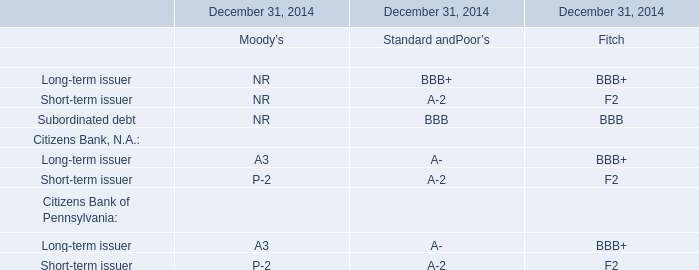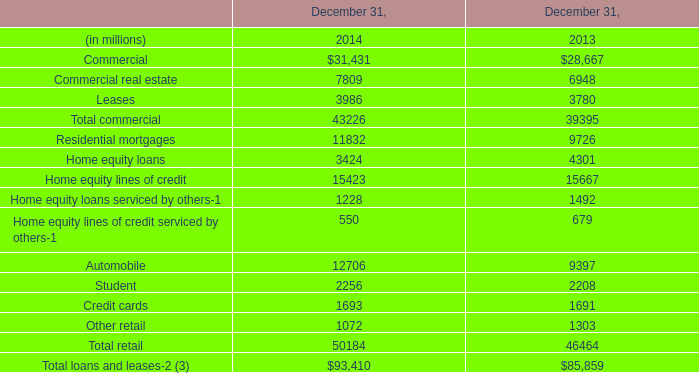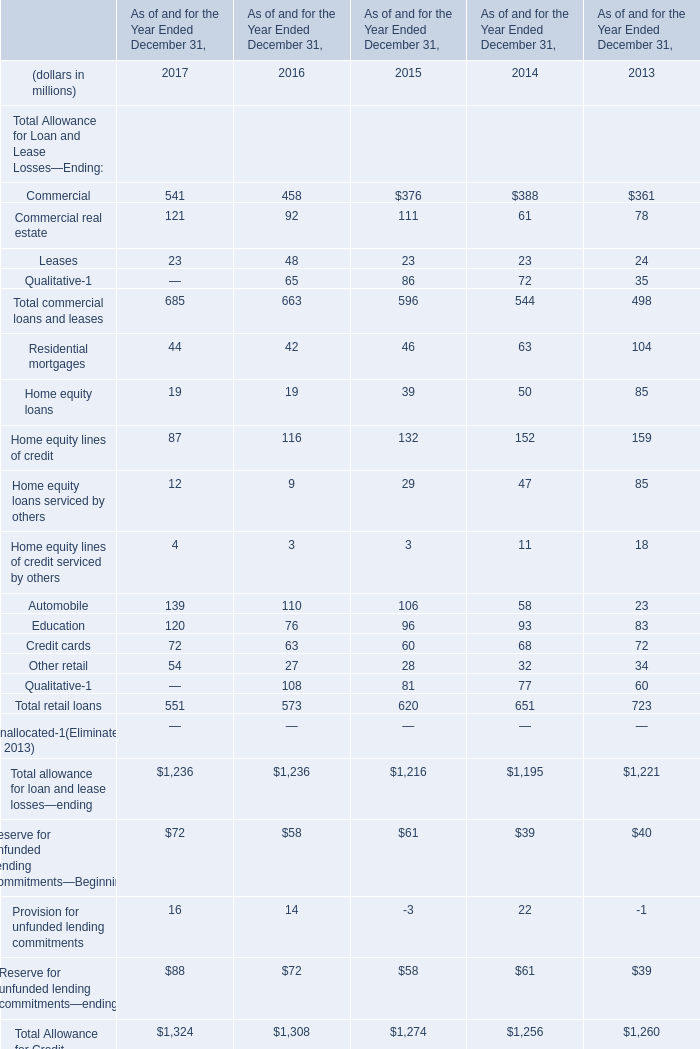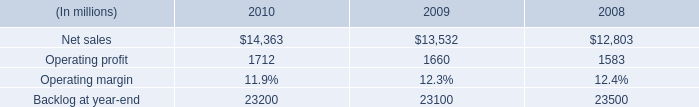What is the average amount of Operating profit of 2009, and Credit cards of December 31, 2013 ? 
Computations: ((1660.0 + 1691.0) / 2)
Answer: 1675.5. 